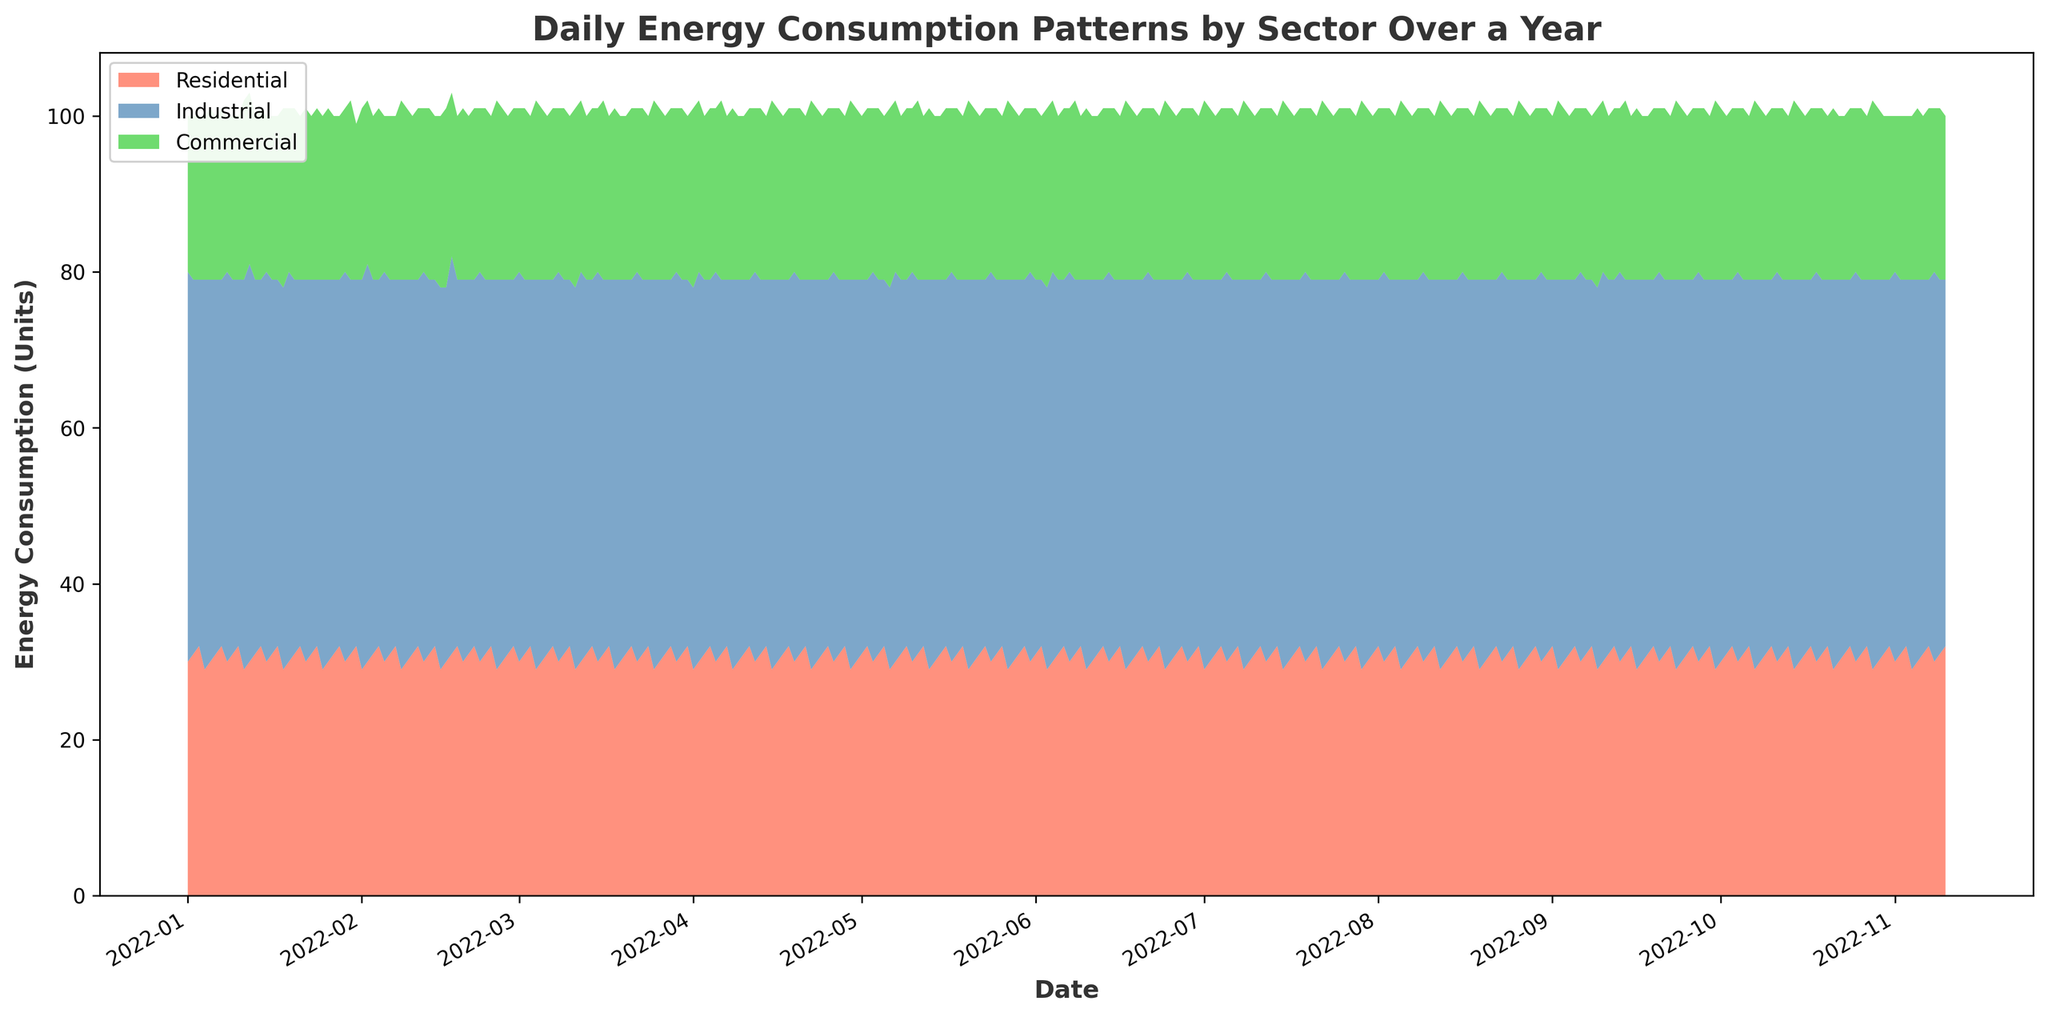what is the trend in energy consumption for the Residential sector over the year? Looking at the area chart, the Residential sector shows a consistent daily consumption pattern throughout the year, with slight variations around the average. The trend does not indicate any significant spikes or drops.
Answer: Consistent Which sector experiences the most variation in daily energy consumption? Observing the stacked area chart, the Industrial sector shows the most variation. It fluctuates within a range with more frequent peaks and valleys compared to the Residential and Commercial sectors.
Answer: Industrial How does the energy consumption of the Commercial sector compare to the Residential sector on February 1st? On February 1st, the Commercial sector's consumption is visually represented by a green area on top of the stack, which seems smaller than the red area for the Residential sector. This indicates that the Residential sector has higher consumption on that date.
Answer: Residential > Commercial What is the combined energy consumption for all sectors on January 5th? By adding the values for each sector on January 5th: Residential (30), Industrial (49), and Commercial (22), the total energy consumption is 30 + 49 + 22 = 101 units.
Answer: 101 units On which date does the Industrial sector's energy consumption peak? The highest peaks for the blue area, representing the Industrial sector, appear around dates like January 1st, August 1st, and October 1st. By closely examining these periods, the peaks seem consistent without an evident single highest peak, so any of these dates hold a significant peak.
Answer: January 1st (or similar dates) Which two sectors combined have the highest energy consumption on April 15th? On April 15th, by visually comparing the areas within the stacked chart, the Residential (red) and Industrial (blue) sectors together cover most of the area towards the top, suggesting their combined consumption is higher than any other combination involving the Commercial sector.
Answer: Residential + Industrial Is the average energy consumption for the Residential sector greater than that of the Commercial sector over the year? By examining the consistent height of the Residential sector's red area and comparing it to the Commercial sector's green area, which is usually smaller and near the top of the stack, it's clear that the Residential sector typically consumes more energy on average daily.
Answer: Yes Which sector consistently consumes the least energy daily? The green area for the Commercial sector is always the smallest across the entire period, indicating it consistently consumes the least energy daily.
Answer: Commercial What is the energy consumption of all sectors combined on the highest consumption day? To find the highest consumption day, identify the peak of the overall area in the stack. This highest point visually appears around some peaks, such as late June. Adding Residential (32), Industrial (47), and Commercial (23) for likely high days gives us the total 32 + 47 + 23 = 102 units.
Answer: 102 units How does the energy consumption pattern of the Residential sector in the first quarter compare to the third quarter? Observing the area chart for the first quarter (January-March) and comparing it to the third quarter (July-September), the Residential sector's red area seems consistent in size for both periods, indicating similar consumption patterns.
Answer: Similar 